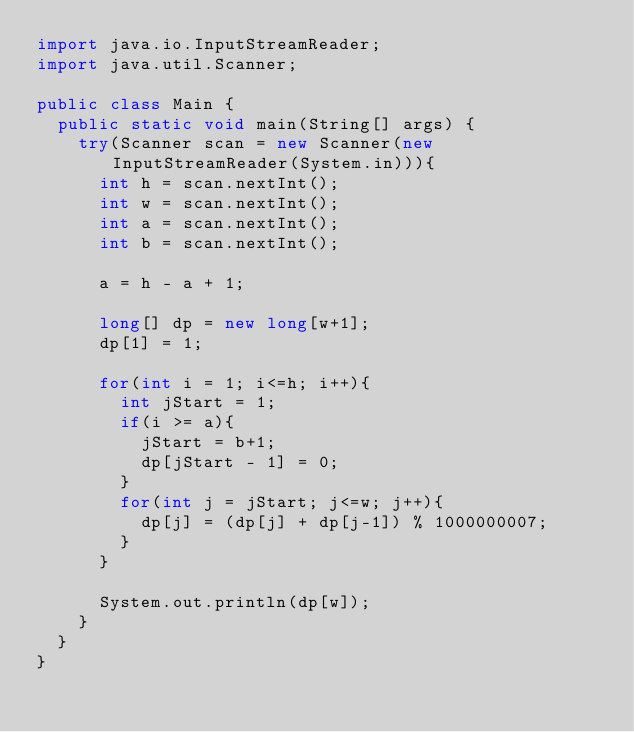Convert code to text. <code><loc_0><loc_0><loc_500><loc_500><_Java_>import java.io.InputStreamReader;
import java.util.Scanner;
 
public class Main {
	public static void main(String[] args) {
		try(Scanner scan = new Scanner(new InputStreamReader(System.in))){
			int h = scan.nextInt();
			int w = scan.nextInt();
			int a = scan.nextInt();
			int b = scan.nextInt();
			
			a = h - a + 1;
			
			long[] dp = new long[w+1];
			dp[1] = 1;
			
			for(int i = 1; i<=h; i++){
				int jStart = 1;
				if(i >= a){
					jStart = b+1;
					dp[jStart - 1] = 0;
				}
				for(int j = jStart; j<=w; j++){
					dp[j] = (dp[j] + dp[j-1]) % 1000000007;
				}
			}
			
			System.out.println(dp[w]);
		}
	}
}
</code> 